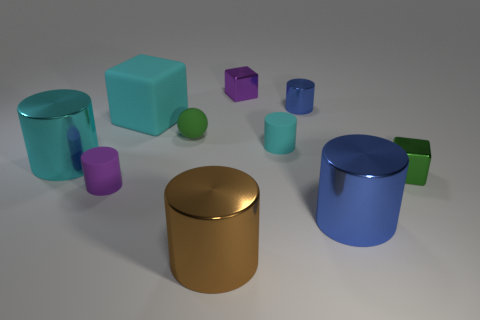There is a object that is the same color as the tiny metal cylinder; what is its size?
Your response must be concise. Large. What size is the purple object that is the same material as the brown cylinder?
Your response must be concise. Small. What number of small green things are left of the cyan cylinder that is to the right of the brown metallic cylinder in front of the large blue shiny object?
Ensure brevity in your answer.  1. There is a large matte cube; does it have the same color as the big shiny thing that is on the left side of the big cyan rubber object?
Keep it short and to the point. Yes. There is a big object that is the same color as the tiny metal cylinder; what shape is it?
Offer a terse response. Cylinder. There is a blue cylinder in front of the green thing behind the cyan object that is on the left side of the cyan matte block; what is its material?
Provide a succinct answer. Metal. There is a tiny green object that is behind the tiny green block; is it the same shape as the brown thing?
Provide a succinct answer. No. What is the small cube that is to the left of the big blue object made of?
Offer a terse response. Metal. How many matte things are either objects or big purple objects?
Your answer should be compact. 4. Are there any brown metal objects of the same size as the brown metal cylinder?
Your answer should be very brief. No. 